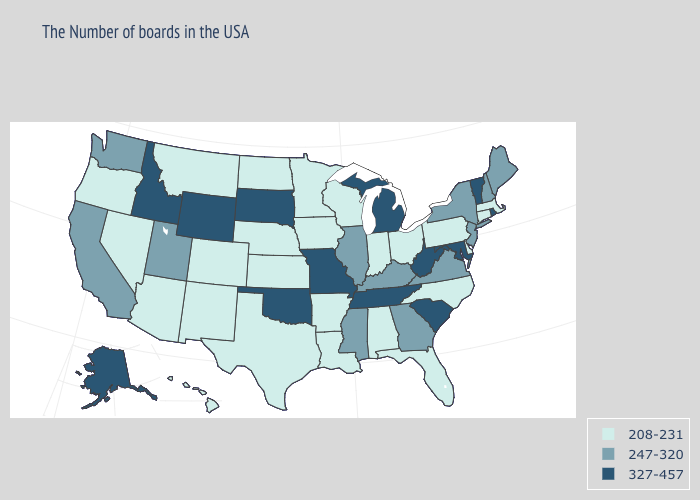What is the highest value in states that border Connecticut?
Write a very short answer. 327-457. Does Mississippi have a lower value than West Virginia?
Be succinct. Yes. Name the states that have a value in the range 208-231?
Be succinct. Massachusetts, Connecticut, Delaware, Pennsylvania, North Carolina, Ohio, Florida, Indiana, Alabama, Wisconsin, Louisiana, Arkansas, Minnesota, Iowa, Kansas, Nebraska, Texas, North Dakota, Colorado, New Mexico, Montana, Arizona, Nevada, Oregon, Hawaii. Name the states that have a value in the range 208-231?
Keep it brief. Massachusetts, Connecticut, Delaware, Pennsylvania, North Carolina, Ohio, Florida, Indiana, Alabama, Wisconsin, Louisiana, Arkansas, Minnesota, Iowa, Kansas, Nebraska, Texas, North Dakota, Colorado, New Mexico, Montana, Arizona, Nevada, Oregon, Hawaii. Among the states that border Iowa , which have the lowest value?
Be succinct. Wisconsin, Minnesota, Nebraska. Among the states that border Ohio , which have the lowest value?
Write a very short answer. Pennsylvania, Indiana. What is the lowest value in the MidWest?
Keep it brief. 208-231. What is the lowest value in the MidWest?
Short answer required. 208-231. Name the states that have a value in the range 327-457?
Concise answer only. Rhode Island, Vermont, Maryland, South Carolina, West Virginia, Michigan, Tennessee, Missouri, Oklahoma, South Dakota, Wyoming, Idaho, Alaska. What is the value of Florida?
Quick response, please. 208-231. What is the value of Nevada?
Give a very brief answer. 208-231. Is the legend a continuous bar?
Be succinct. No. Which states have the lowest value in the South?
Short answer required. Delaware, North Carolina, Florida, Alabama, Louisiana, Arkansas, Texas. Among the states that border Louisiana , does Arkansas have the highest value?
Quick response, please. No. Which states have the lowest value in the MidWest?
Be succinct. Ohio, Indiana, Wisconsin, Minnesota, Iowa, Kansas, Nebraska, North Dakota. 